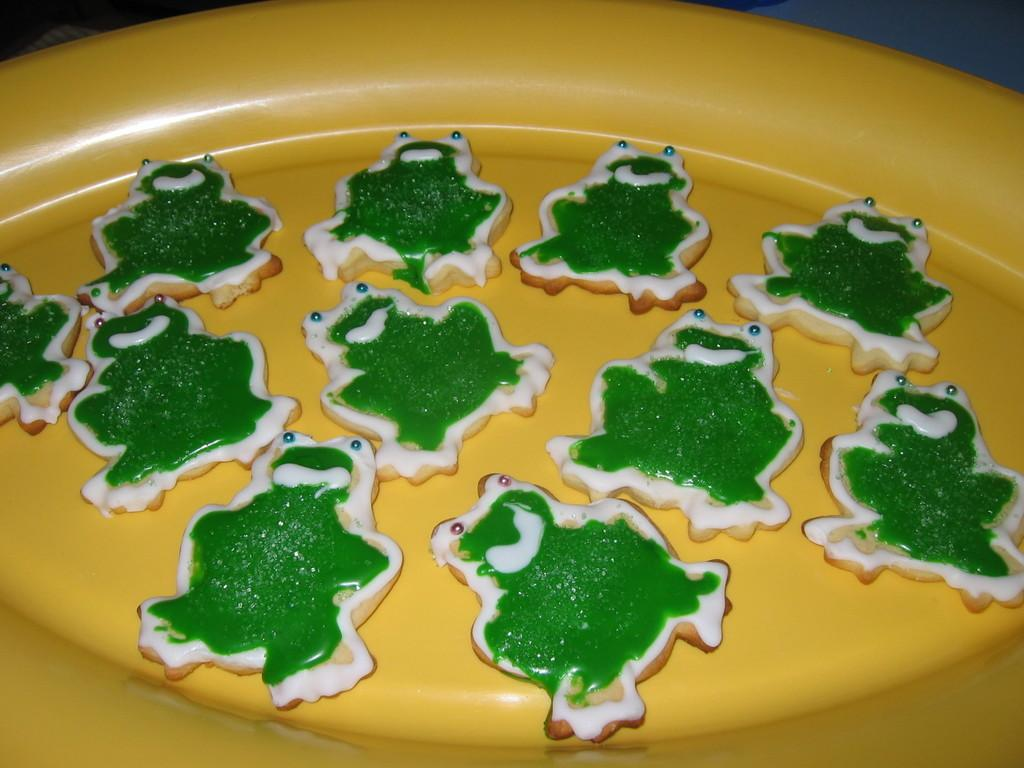What is on the plate that is visible in the image? The plate contains frog-shaped cookies. What is the shape of the cookies on the plate? The cookies are frog-shaped. What is on top of the cookies? The cookies have cream on them. How many tomatoes are on the plate in the image? There are no tomatoes present on the plate in the image; it contains frog-shaped cookies with cream on them. 